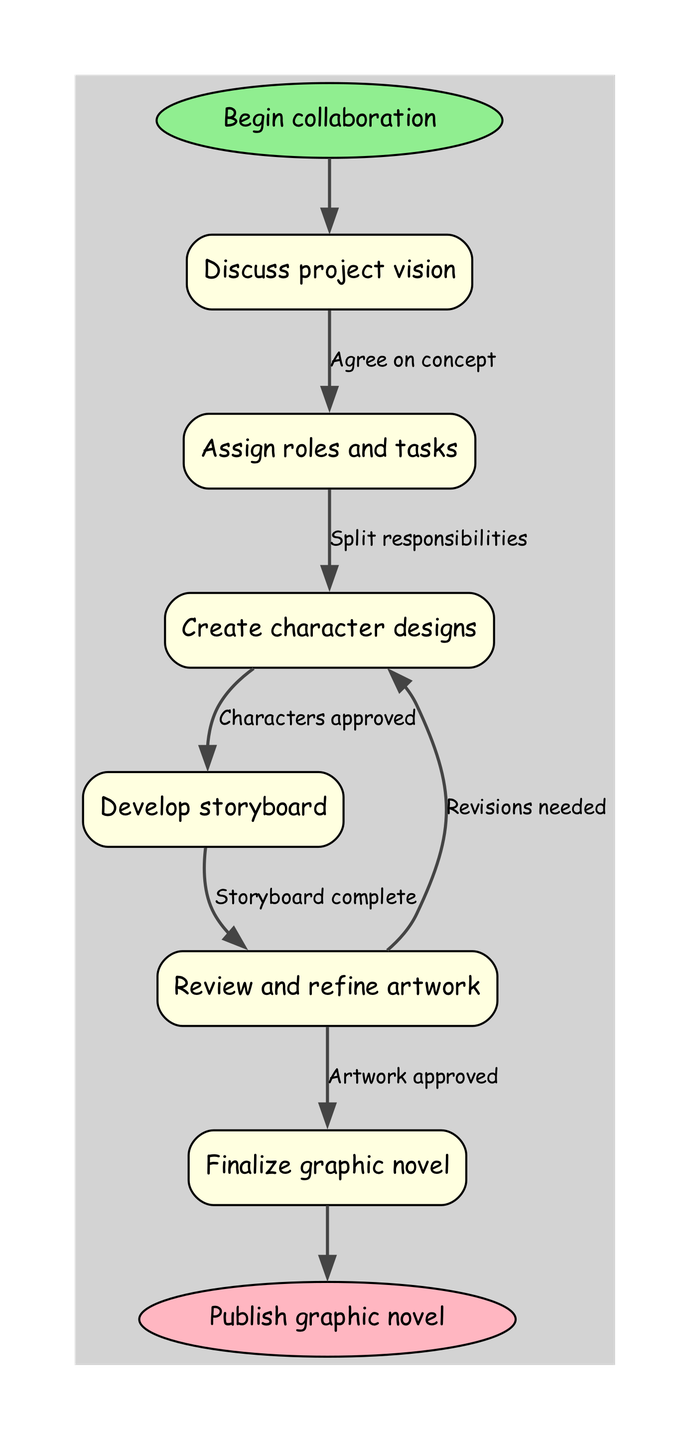what is the first step in the collaboration process? The diagram begins with the node labeled 'Begin collaboration,' which indicates the starting point of the process. Therefore, the first step is to 'Discuss project vision.'
Answer: Discuss project vision how many total nodes are in the diagram? Counting all the nodes listed in the diagram, there are six nodes representing different steps in the collaboration process.
Answer: 6 what is the relationship between the 'Review and refine artwork' and 'Create character designs' nodes? The diagram shows that from 'Review and refine artwork,' there is an option to go back to 'Create character designs' if revisions are needed. This demonstrates a feedback loop between these two stages.
Answer: Revisions needed what is the last action before publishing the graphic novel? According to the flow chart, the last action performed before reaching the end node 'Publish graphic novel' is 'Finalize graphic novel.' This indicates that all prior tasks must be completed before publication.
Answer: Finalize graphic novel what task follows the 'Assign roles and tasks'? The flowchart indicates that the task that follows 'Assign roles and tasks' is 'Create character designs.' This is a clear progression in the workflow after roles are clearly defined.
Answer: Create character designs which node does 'Develop storyboard' lead to? From the diagram, 'Develop storyboard' directly leads to 'Review and refine artwork,' indicating that this is the next step after the storyboard has been completed.
Answer: Review and refine artwork how does a completed 'Storyboard' affect the next stage? When the 'Storyboard' is complete, it confirms that the project has established a visual sequence for the story. Following this, the next step is 'Review and refine artwork,' indicating that the artwork will now be reviewed based on the storyboard.
Answer: Storyboard complete which step involves the approval of character designs? The step that involves approval for character designs is labeled 'Characters approved.' This step ensures that all character designs agreed upon in the workflow are finalized.
Answer: Characters approved what happens if artwork does not get approved? If the artwork does not get approved, the flowchart indicates that 'Revisions needed' will lead back to the 'Create character designs' node, suggesting that adjustments may be made before proceeding further in the process.
Answer: Revisions needed 